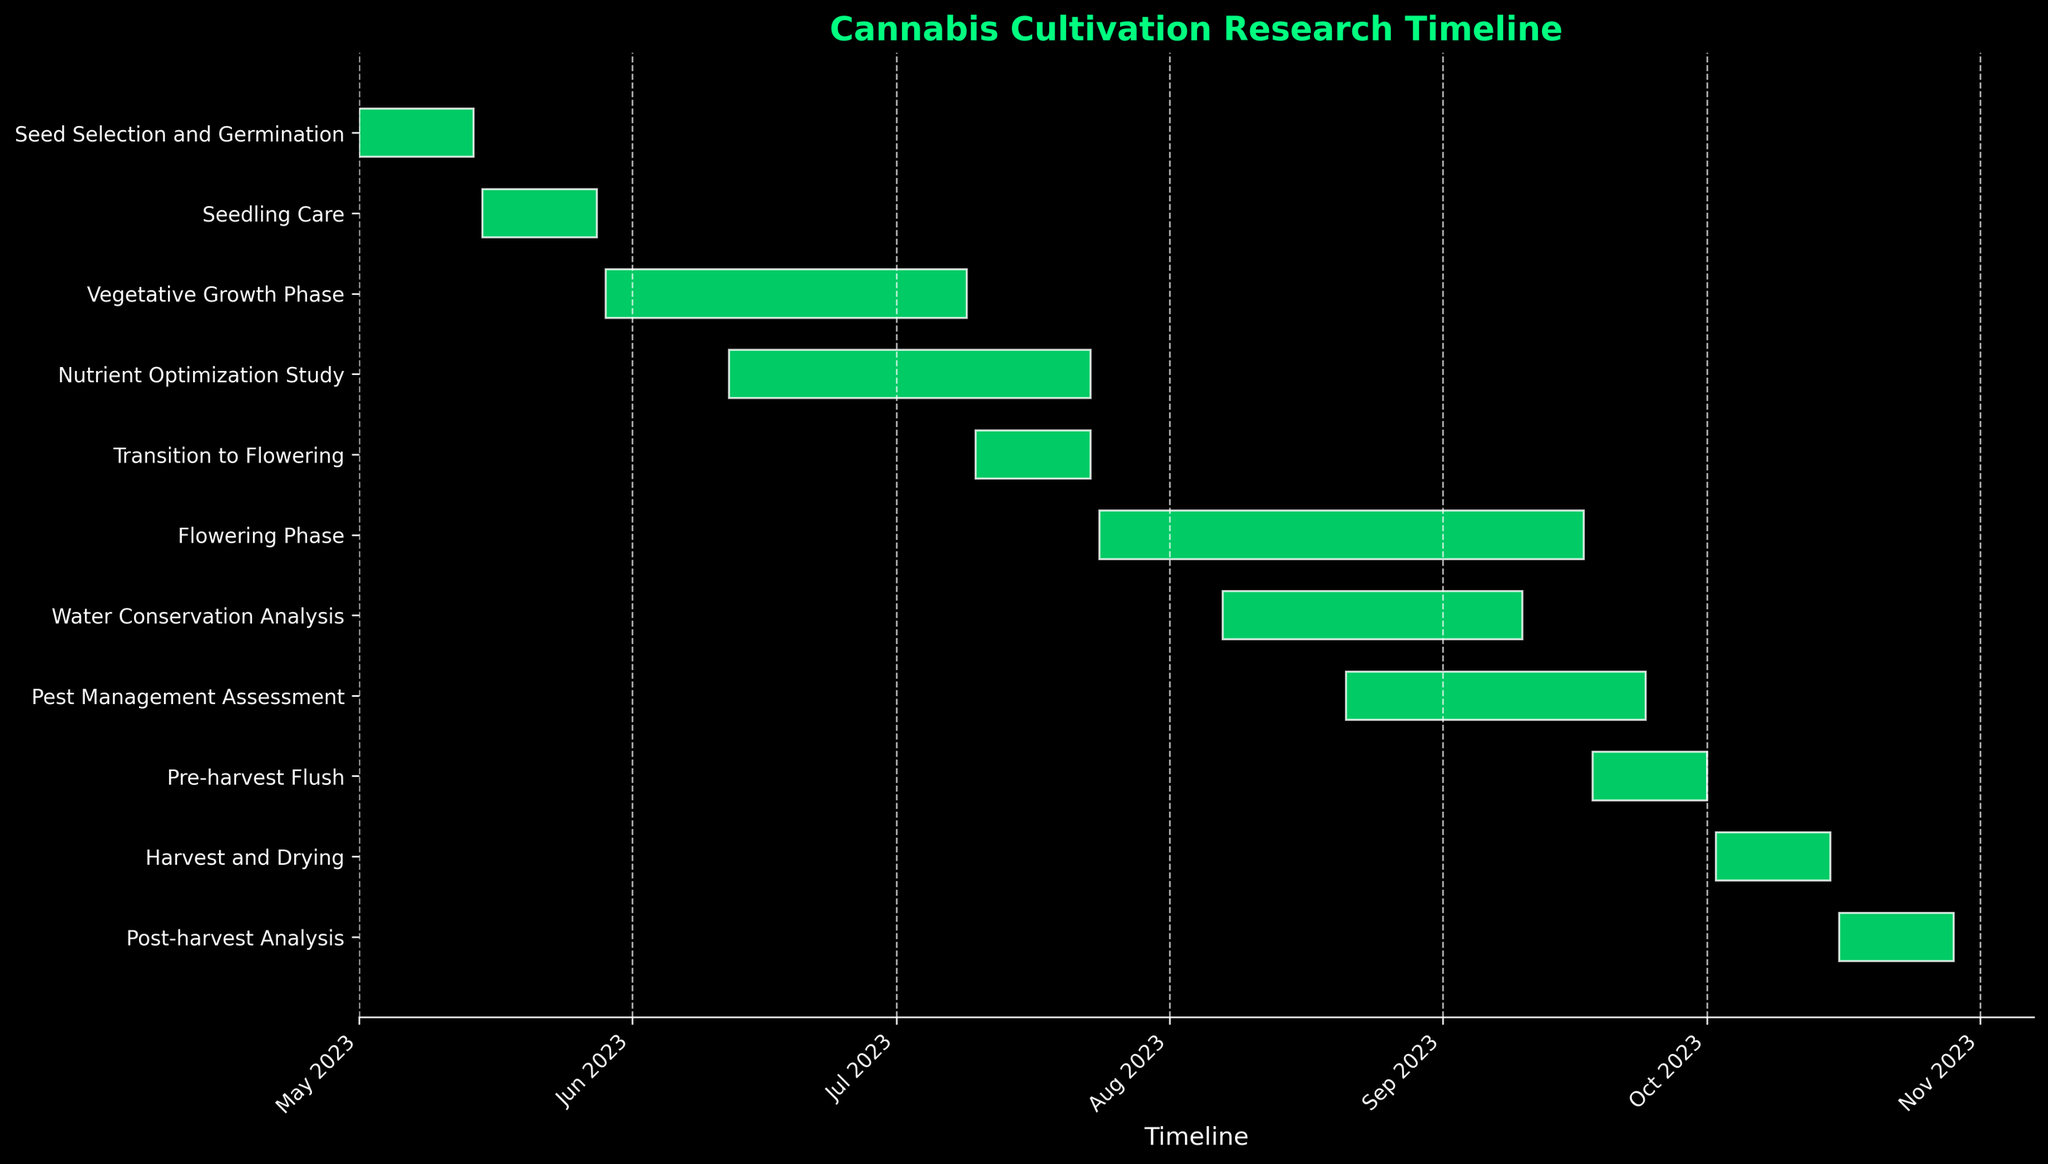What is the title of the chart? The title is typically displayed at the top of the chart in larger font size and distinct color.
Answer: Cannabis Cultivation Research Timeline What is the duration of the Vegetative Growth Phase? The Vegetative Growth Phase starts on 2023-05-29 and ends on 2023-07-09. The number of days between these dates is 42 days.
Answer: 42 days Which research task spans the longest duration? By comparing the duration of all tasks in the chart, the task with the longest bar represents the longest duration. The Flowering Phase bar is the longest.
Answer: Flowering Phase What is the total time spent on Pre-harvest Flush and Harvest and Drying combined? The Pre-harvest Flush spans from 2023-09-18 to 2023-10-01, lasting 14 days, and Harvest and Drying spans from 2023-10-02 to 2023-10-15, also lasting 14 days. Adding these together gives 14 + 14 days.
Answer: 28 days Which tasks overlap with the Flowering Phase? The Flowering Phase spans from 2023-07-24 to 2023-09-17. By looking at the timeline, the Water Conservation Analysis (2023-08-07 to 2023-09-10) and Pest Management Assessment (2023-08-21 to 2023-09-24) overlap with the Flowering Phase.
Answer: Water Conservation Analysis and Pest Management Assessment How many phases are there after the Transition to Flowering? From the chart, after the Transition to Flowering phase, there are four phases: Flowering Phase, Water Conservation Analysis, Pest Management Assessment, Pre-harvest Flush, Harvest and Drying, and Post-harvest Analysis.
Answer: 5 phases What is the average duration of all research tasks? To find the average duration, calculate the duration of all tasks, sum them up, and divide by the number of tasks: (14 + 14 + 42 + 42 + 14 + 56 + 34 + 34 + 14 + 14 + 14) = 292 days / 11 tasks.
Answer: 26.5 days Which task immediately follows the Seedling Care phase? According to the chart, the Seedling Care phase ends on 2023-05-28, and the next task starting on 2023-05-29 is the Vegetative Growth Phase.
Answer: Vegetative Growth Phase What is the color of the horizontal bars representing the tasks? The color of the bars can be seen as springgreen.
Answer: springgreen When does the Post-harvest Analysis begin and end? The chart shows that the Post-harvest Analysis begins on 2023-10-16 and ends on 2023-10-29.
Answer: 2023-10-16 to 2023-10-29 